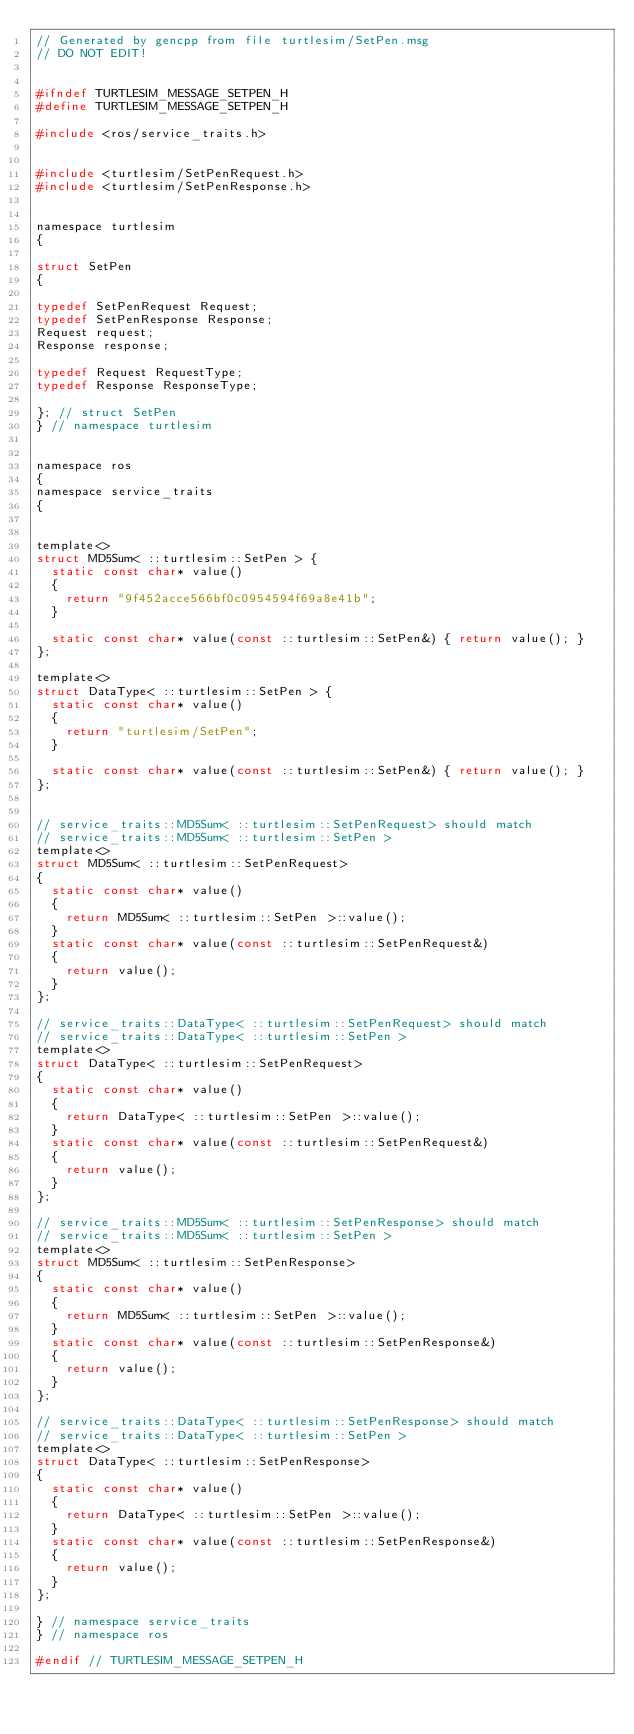Convert code to text. <code><loc_0><loc_0><loc_500><loc_500><_C_>// Generated by gencpp from file turtlesim/SetPen.msg
// DO NOT EDIT!


#ifndef TURTLESIM_MESSAGE_SETPEN_H
#define TURTLESIM_MESSAGE_SETPEN_H

#include <ros/service_traits.h>


#include <turtlesim/SetPenRequest.h>
#include <turtlesim/SetPenResponse.h>


namespace turtlesim
{

struct SetPen
{

typedef SetPenRequest Request;
typedef SetPenResponse Response;
Request request;
Response response;

typedef Request RequestType;
typedef Response ResponseType;

}; // struct SetPen
} // namespace turtlesim


namespace ros
{
namespace service_traits
{


template<>
struct MD5Sum< ::turtlesim::SetPen > {
  static const char* value()
  {
    return "9f452acce566bf0c0954594f69a8e41b";
  }

  static const char* value(const ::turtlesim::SetPen&) { return value(); }
};

template<>
struct DataType< ::turtlesim::SetPen > {
  static const char* value()
  {
    return "turtlesim/SetPen";
  }

  static const char* value(const ::turtlesim::SetPen&) { return value(); }
};


// service_traits::MD5Sum< ::turtlesim::SetPenRequest> should match
// service_traits::MD5Sum< ::turtlesim::SetPen >
template<>
struct MD5Sum< ::turtlesim::SetPenRequest>
{
  static const char* value()
  {
    return MD5Sum< ::turtlesim::SetPen >::value();
  }
  static const char* value(const ::turtlesim::SetPenRequest&)
  {
    return value();
  }
};

// service_traits::DataType< ::turtlesim::SetPenRequest> should match
// service_traits::DataType< ::turtlesim::SetPen >
template<>
struct DataType< ::turtlesim::SetPenRequest>
{
  static const char* value()
  {
    return DataType< ::turtlesim::SetPen >::value();
  }
  static const char* value(const ::turtlesim::SetPenRequest&)
  {
    return value();
  }
};

// service_traits::MD5Sum< ::turtlesim::SetPenResponse> should match
// service_traits::MD5Sum< ::turtlesim::SetPen >
template<>
struct MD5Sum< ::turtlesim::SetPenResponse>
{
  static const char* value()
  {
    return MD5Sum< ::turtlesim::SetPen >::value();
  }
  static const char* value(const ::turtlesim::SetPenResponse&)
  {
    return value();
  }
};

// service_traits::DataType< ::turtlesim::SetPenResponse> should match
// service_traits::DataType< ::turtlesim::SetPen >
template<>
struct DataType< ::turtlesim::SetPenResponse>
{
  static const char* value()
  {
    return DataType< ::turtlesim::SetPen >::value();
  }
  static const char* value(const ::turtlesim::SetPenResponse&)
  {
    return value();
  }
};

} // namespace service_traits
} // namespace ros

#endif // TURTLESIM_MESSAGE_SETPEN_H
</code> 